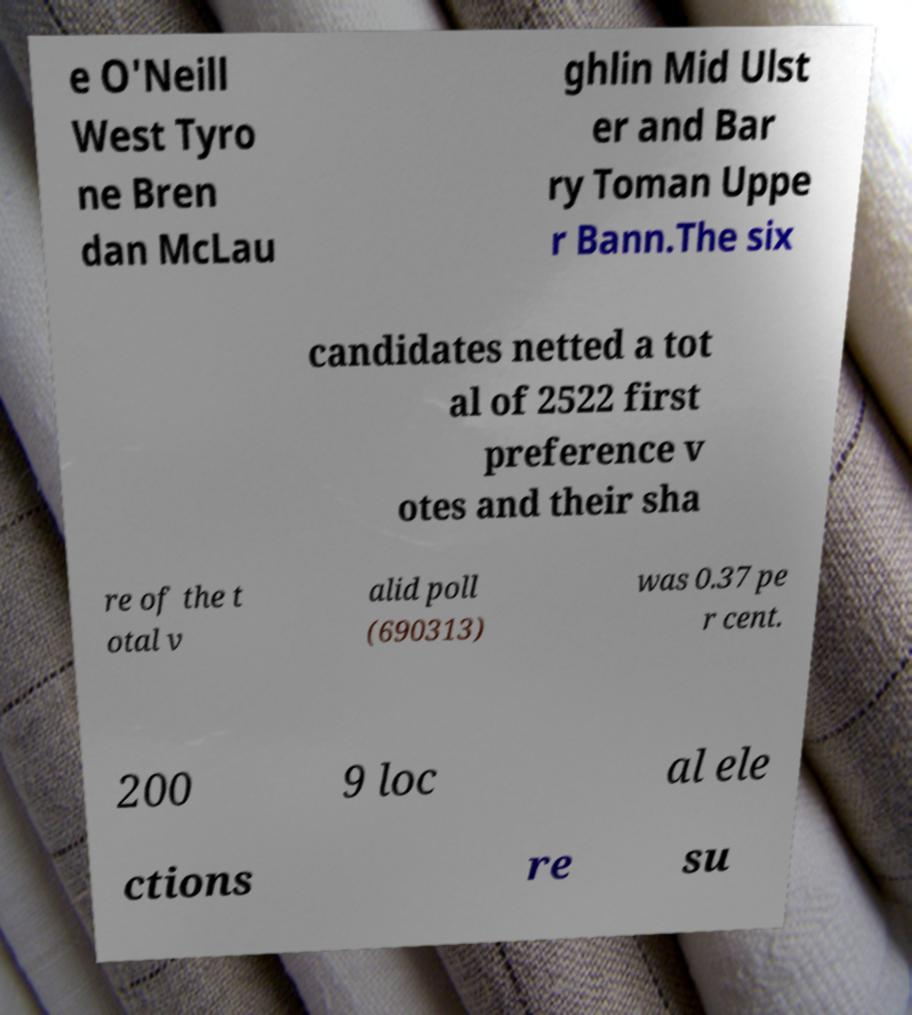For documentation purposes, I need the text within this image transcribed. Could you provide that? e O'Neill West Tyro ne Bren dan McLau ghlin Mid Ulst er and Bar ry Toman Uppe r Bann.The six candidates netted a tot al of 2522 first preference v otes and their sha re of the t otal v alid poll (690313) was 0.37 pe r cent. 200 9 loc al ele ctions re su 